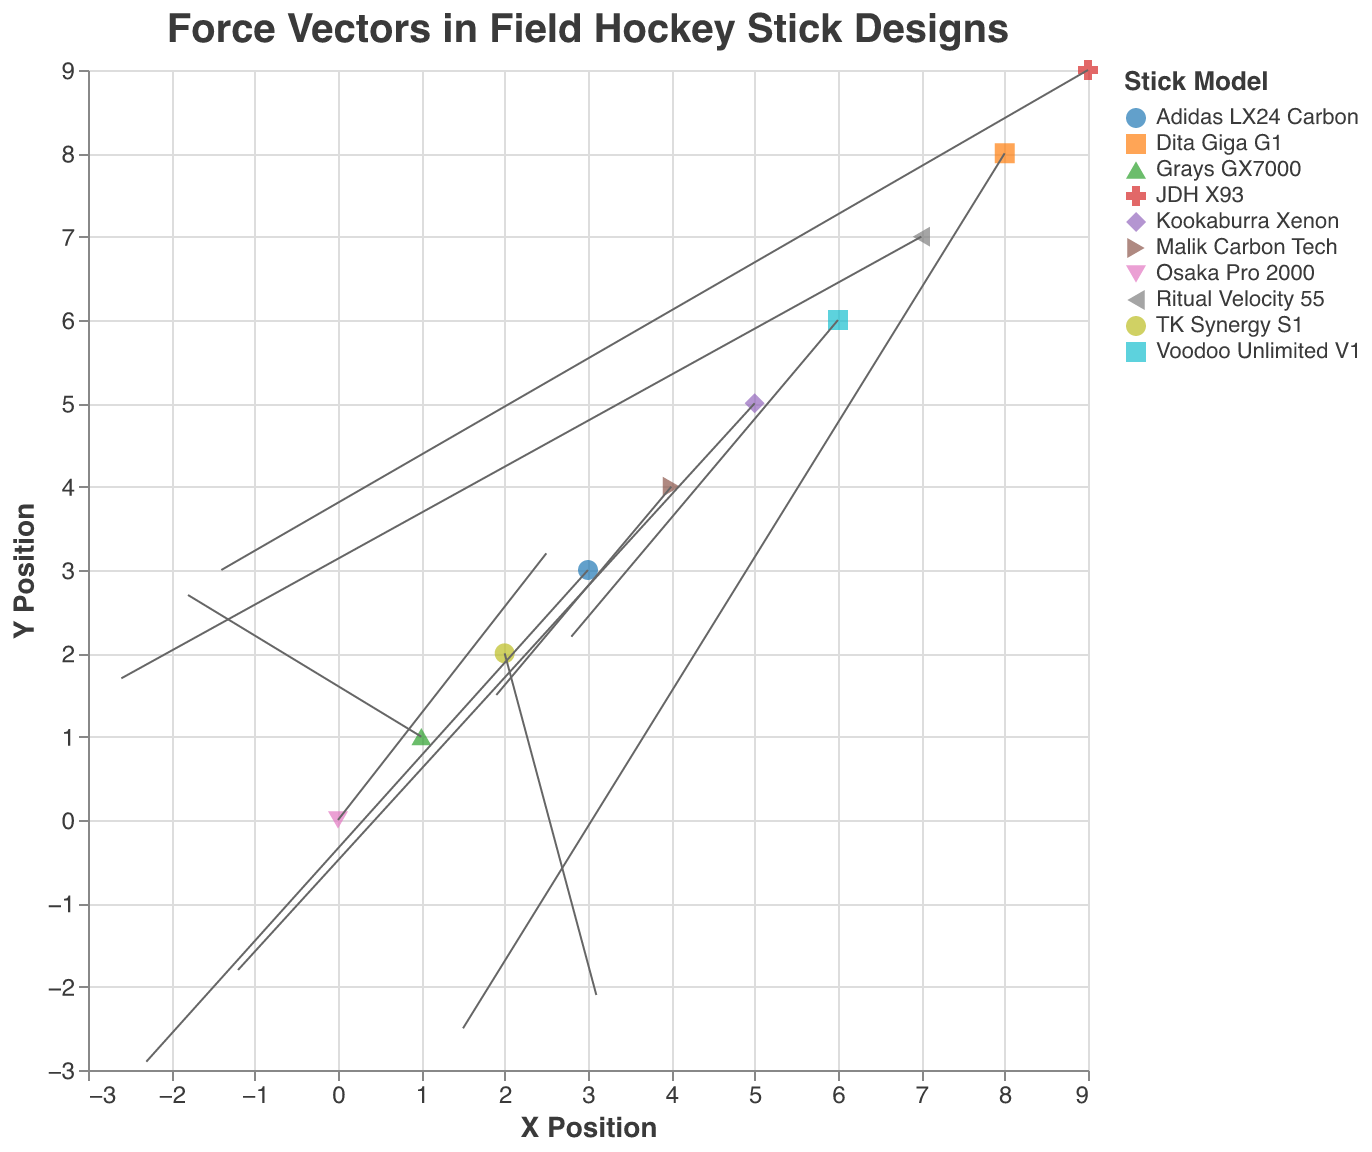What is the title of the plot? The title is displayed at the top of the plot. It reads "Force Vectors in Field Hockey Stick Designs".
Answer: Force Vectors in Field Hockey Stick Designs How many different stick models are represented in the plot? Each stick model has a unique color and shape on the plot. By counting the different colors and shapes, we can determine that there are ten stick models.
Answer: 10 Which axis represents the X Position? The axis labeled "X Position" at the bottom of the plot represents the X Position.
Answer: X Axis Which stick model has the highest ball control rating? By referring to the tooltips that display ball control ratings for each stick, we can see that the Osaka Pro 2000 has the highest ball control rating of 8.5.
Answer: Osaka Pro 2000 What is the average ball control rating of all the stick models? Sum the ball control ratings of all ten sticks (8.5 + 7.8 + 8.2 + 7.5 + 8.1 + 7.9 + 8.3 + 8.0 + 7.7 + 8.4) = 80.4, then divide by the number of stick models, which is 10. 80.4 / 10 = 8.04.
Answer: 8.04 What is the total force vector length (√(u² + v²)) for the Kookaburra Xenon stick? Calculate the vector length for Kookaburra Xenon using its coordinates: √((-1.2)² + (-1.8)²) = √(1.44 + 3.24) = √4.68 ≈ 2.16.
Answer: 2.16 Which stick model has a higher passing accuracy, the TK Synergy S1 or the Dita Giga G1? The tooltip data shows passing accuracy for TK Synergy S1 as 8.5 and for Dita Giga G1 as 7.8. 8.5 (TK Synergy S1) is higher than 7.8 (Dita Giga G1).
Answer: TK Synergy S1 Between Adidas LX24 Carbon and Grays GX7000, which one has a greater negative force vector in the u direction? Check the u values in the dataset: Adidas LX24 Carbon has u = -2.3 and Grays GX7000 has u = -1.8. -2.3 is more negative than -1.8.
Answer: Adidas LX24 Carbon Which stick model has the smallest force vector between the Adidas LX24 Carbon and the Ritual Velocity 55? Calculate the vector lengths: 
   - Adidas LX24 Carbon: √((-2.3)² + (-2.9)²) = √(5.29 + 8.41) = √13.7 ≈ 3.7
   - Ritual Velocity 55: √((-2.6)² + 1.7²) = √(6.76 + 2.89) = √9.65 ≈ 3.11. 
Ritual Velocity 55 has a smaller vector length.
Answer: Ritual Velocity 55 What direction is the force vector for the JDH X93 stick pointing? By looking at the plot, the arrow representing the JDH X93 stick has a positive u of -1.4 and a positive v of 3.0, pointing up and slightly to the left.
Answer: Up and to the left Which stick model’s force vector is pointing in the negative u and positive v directions? By examining the direction of the arrows, we see that the Grays GX7000 stick has a negative u value (-1.8) and a positive v value (2.7), indicating it points in the negative u and positive v directions.
Answer: Grays GX7000 